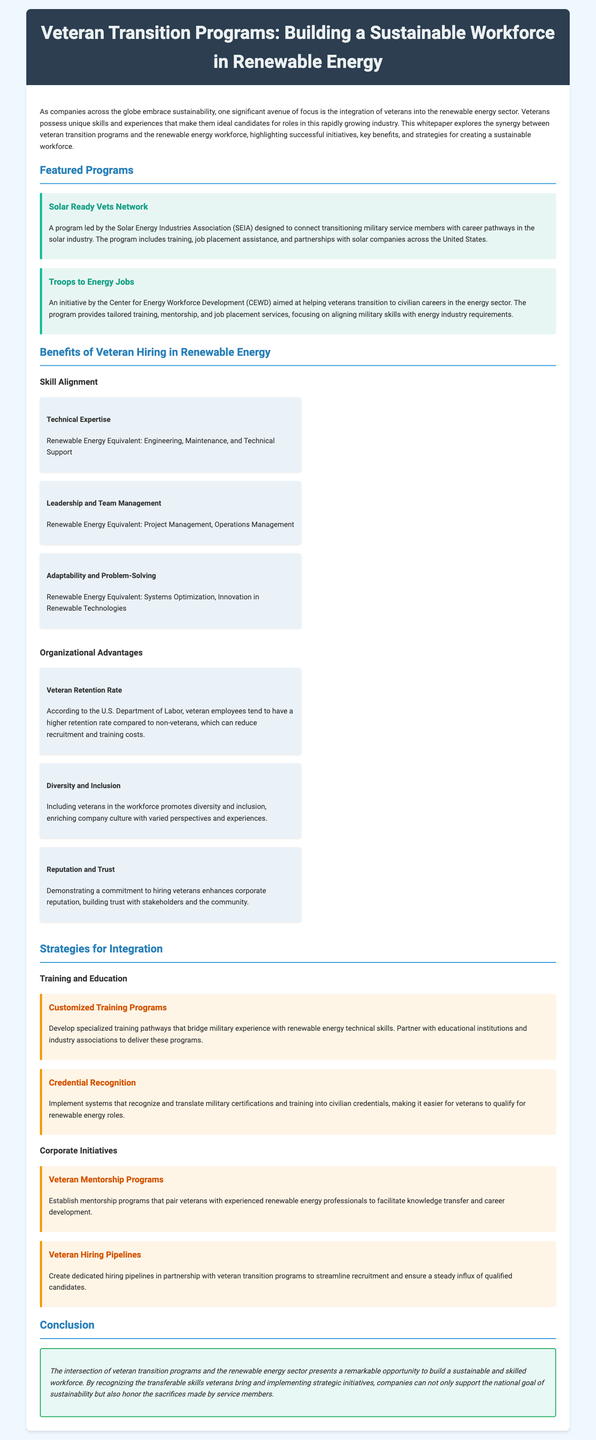What is the main focus of this whitepaper? The whitepaper focuses on the integration of veterans into the renewable energy sector and the benefits of veteran transition programs.
Answer: integration of veterans into the renewable energy sector Who leads the Solar Ready Vets Network? The Solar Ready Vets Network is led by the Solar Energy Industries Association (SEIA).
Answer: Solar Energy Industries Association What kind of training does the Troops to Energy Jobs program provide? The Troops to Energy Jobs program provides tailored training, mentorship, and job placement services.
Answer: tailored training What is one benefit of hiring veterans according to the document? One benefit is the higher retention rate of veteran employees compared to non-veterans.
Answer: higher retention rate What are customized training programs designed to do? Customized training programs are designed to bridge military experience with renewable energy technical skills.
Answer: bridge military experience with renewable energy technical skills What is a key strategy for recognizing military experience? Implementing systems that recognize and translate military certifications and training into civilian credentials.
Answer: Credential Recognition What do mentorship programs aim to do? Mentorship programs aim to facilitate knowledge transfer and career development for veterans.
Answer: facilitate knowledge transfer and career development How can companies ensure a steady influx of qualified candidates? Companies can create dedicated hiring pipelines in partnership with veteran transition programs.
Answer: dedicated hiring pipelines What is the document type? The document is a whitepaper discussing veteran transition programs and their link to workforce sustainability.
Answer: whitepaper 